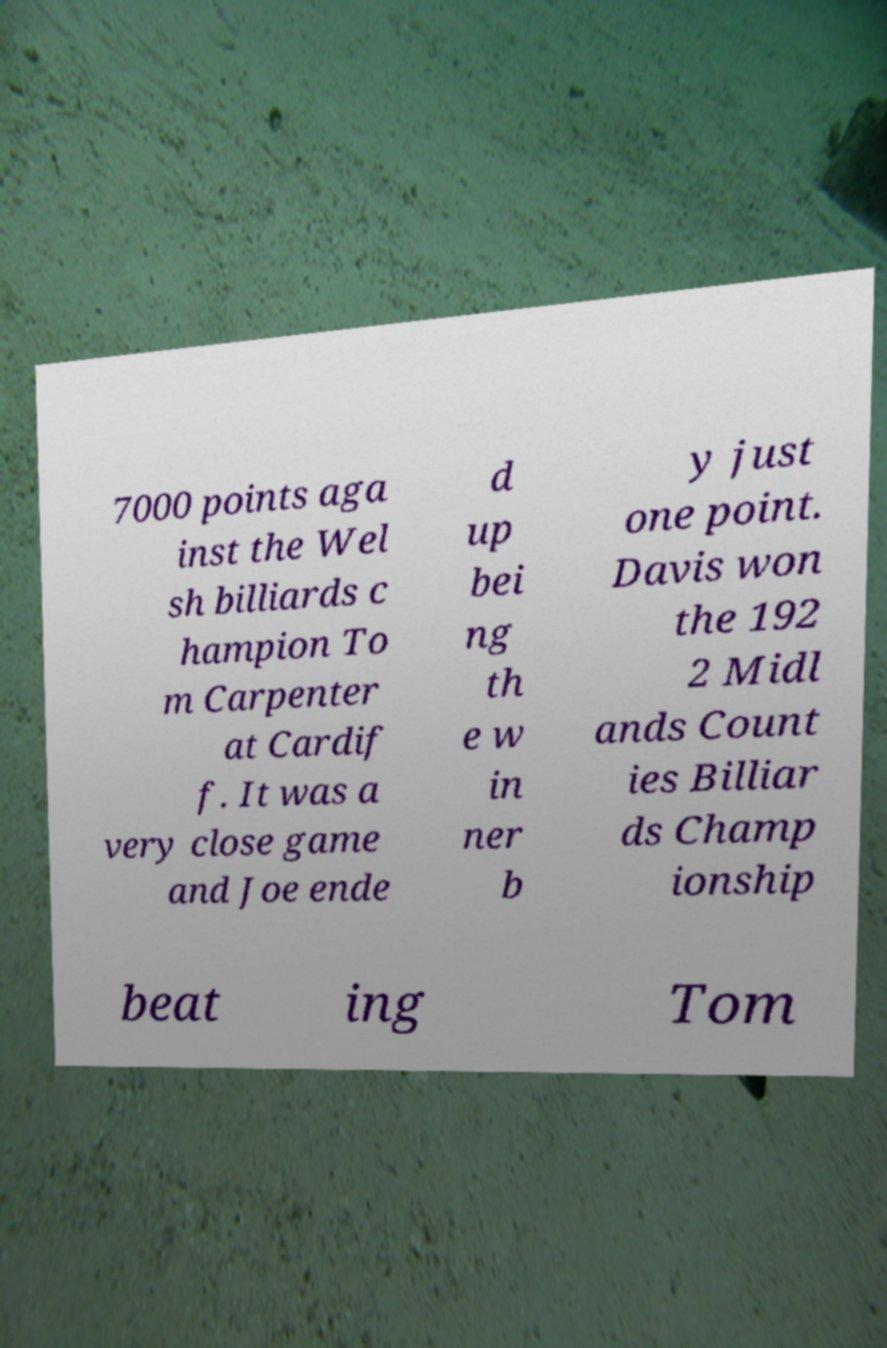I need the written content from this picture converted into text. Can you do that? 7000 points aga inst the Wel sh billiards c hampion To m Carpenter at Cardif f. It was a very close game and Joe ende d up bei ng th e w in ner b y just one point. Davis won the 192 2 Midl ands Count ies Billiar ds Champ ionship beat ing Tom 